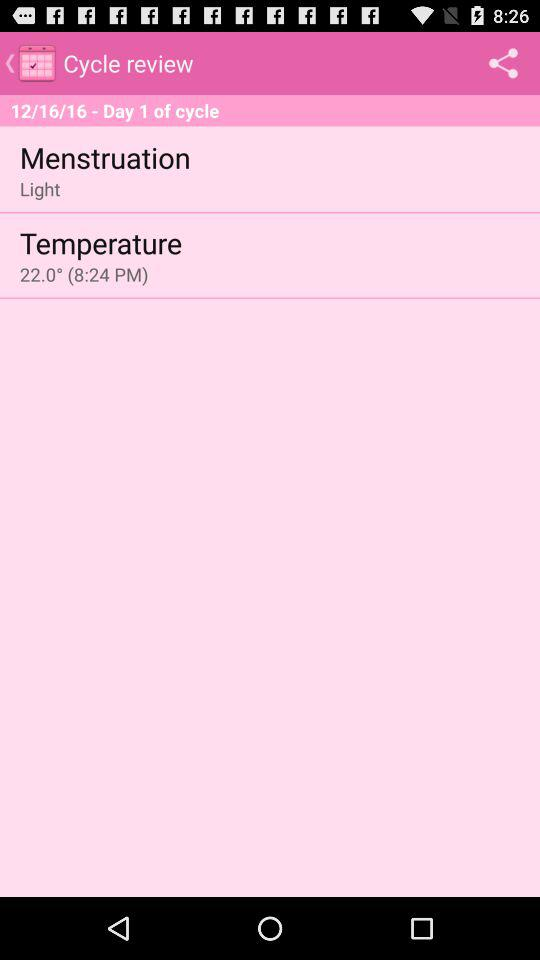At what time temperature is updated? The temperature is updated at 8:24 PM. 